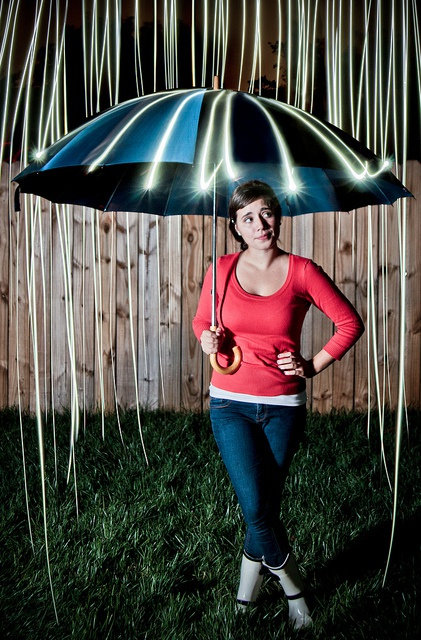Describe the objects in this image and their specific colors. I can see people in black, salmon, brown, and lightpink tones and umbrella in black, blue, white, and darkblue tones in this image. 